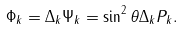<formula> <loc_0><loc_0><loc_500><loc_500>\Phi _ { k } = \Delta _ { k } \Psi _ { k } = \sin ^ { 2 } \theta \Delta _ { k } P _ { k } .</formula> 